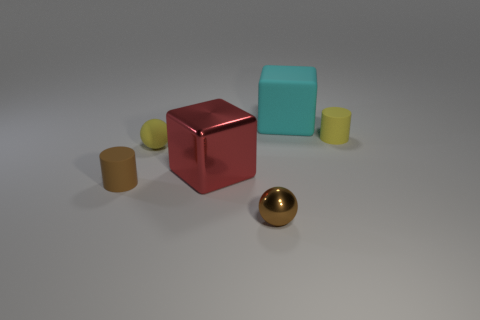Add 1 red shiny blocks. How many objects exist? 7 Subtract all balls. How many objects are left? 4 Add 6 metal balls. How many metal balls are left? 7 Add 1 small shiny things. How many small shiny things exist? 2 Subtract 1 yellow cylinders. How many objects are left? 5 Subtract all tiny balls. Subtract all large cyan cubes. How many objects are left? 3 